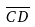<formula> <loc_0><loc_0><loc_500><loc_500>\overline { C D }</formula> 